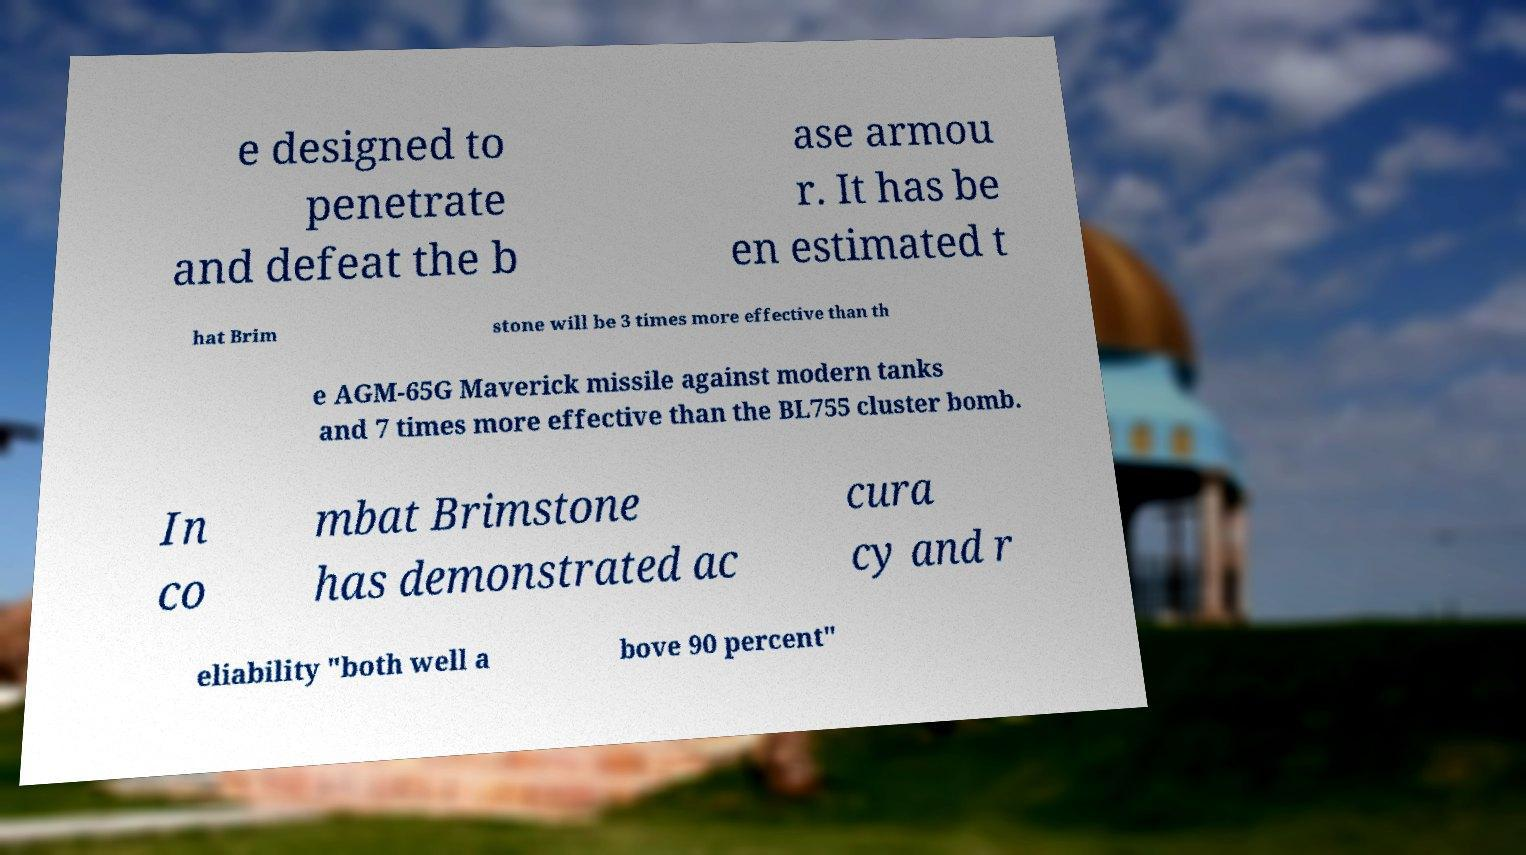Can you accurately transcribe the text from the provided image for me? e designed to penetrate and defeat the b ase armou r. It has be en estimated t hat Brim stone will be 3 times more effective than th e AGM-65G Maverick missile against modern tanks and 7 times more effective than the BL755 cluster bomb. In co mbat Brimstone has demonstrated ac cura cy and r eliability "both well a bove 90 percent" 